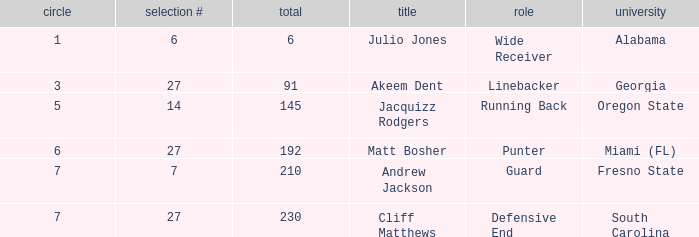Which overall's pick number was 14? 145.0. 